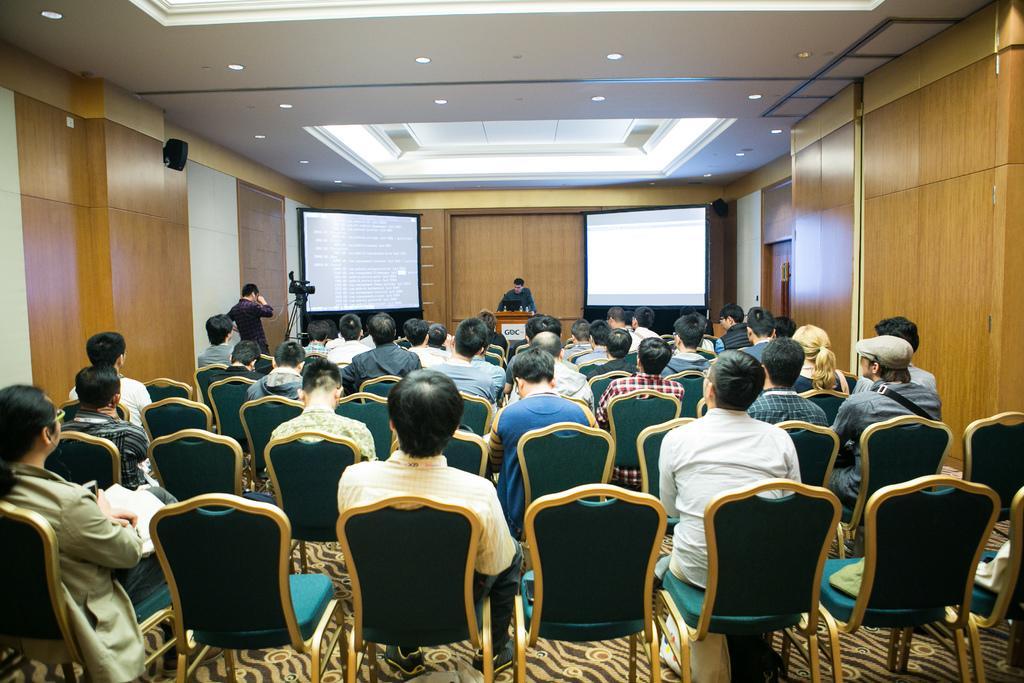How would you summarize this image in a sentence or two? this picture is taken inside a auditorium. There many people in the room and all are seated in the chairs. One man is standing on the dais at the podium. On two sides of him there are screens and text is displayed on it. The other man at the left is standing and clicking pictures and also there is another camera in front of him on tripod stand. There are many lights to the ceiling and the room has wooden wall. 